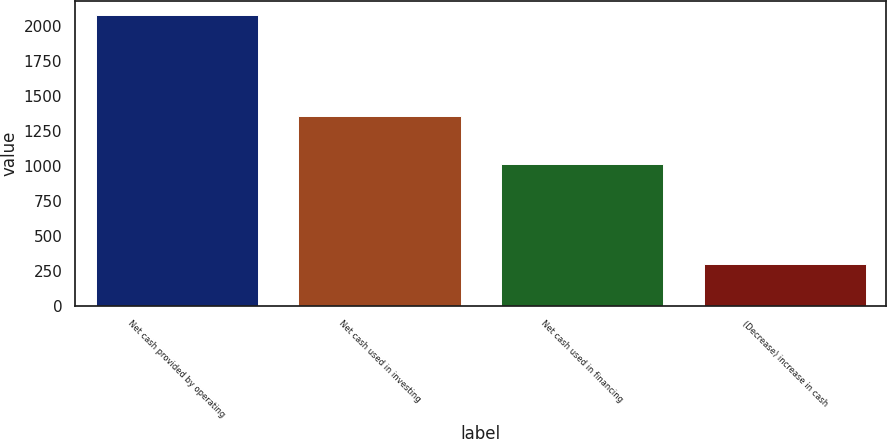Convert chart to OTSL. <chart><loc_0><loc_0><loc_500><loc_500><bar_chart><fcel>Net cash provided by operating<fcel>Net cash used in investing<fcel>Net cash used in financing<fcel>(Decrease) increase in cash<nl><fcel>2079<fcel>1358<fcel>1017<fcel>296<nl></chart> 